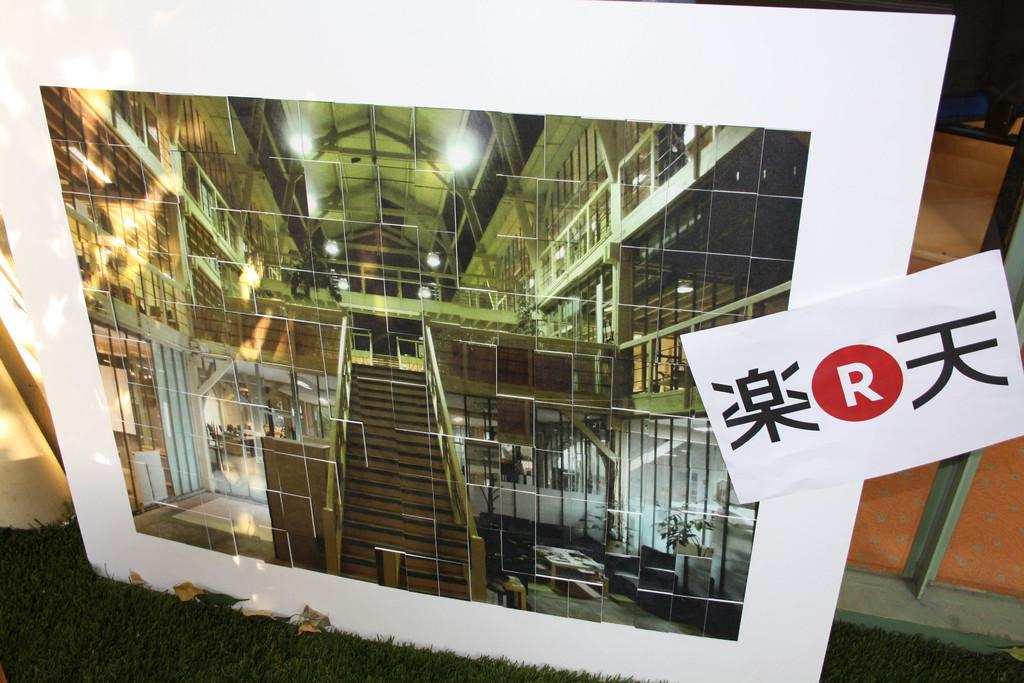What is the main subject of the image? There is a photo in the image. What type of surface is visible at the bottom of the image? There is grass at the bottom of the image. What can be seen in the background of the image? There are objects in the background of the image. What is written or displayed on the photo? There is text on the photo. Can you hear the voice of the rabbits in the image? There are no rabbits or voices present in the image. 